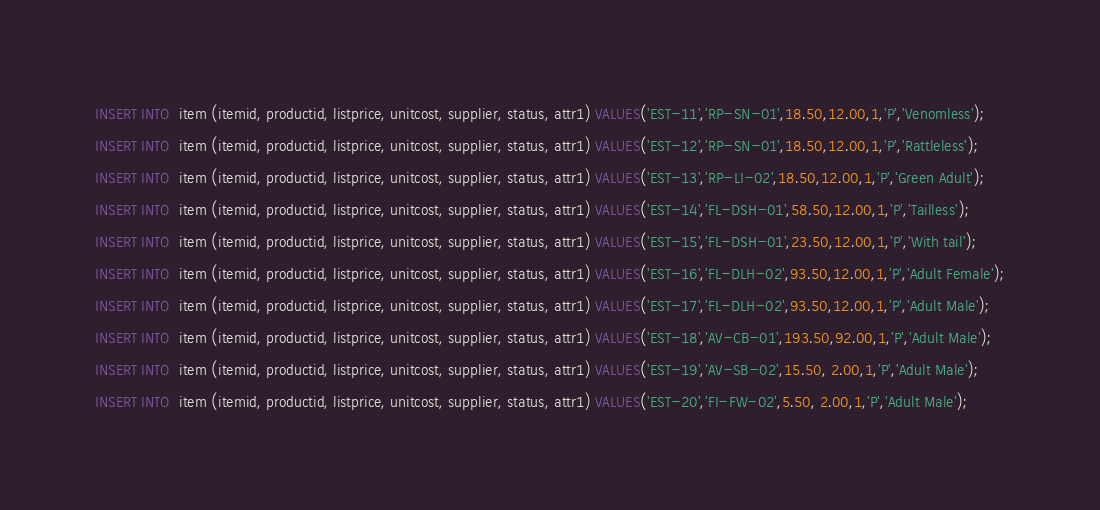Convert code to text. <code><loc_0><loc_0><loc_500><loc_500><_SQL_>INSERT INTO  item (itemid, productid, listprice, unitcost, supplier, status, attr1) VALUES('EST-11','RP-SN-01',18.50,12.00,1,'P','Venomless');
INSERT INTO  item (itemid, productid, listprice, unitcost, supplier, status, attr1) VALUES('EST-12','RP-SN-01',18.50,12.00,1,'P','Rattleless');
INSERT INTO  item (itemid, productid, listprice, unitcost, supplier, status, attr1) VALUES('EST-13','RP-LI-02',18.50,12.00,1,'P','Green Adult');
INSERT INTO  item (itemid, productid, listprice, unitcost, supplier, status, attr1) VALUES('EST-14','FL-DSH-01',58.50,12.00,1,'P','Tailless');
INSERT INTO  item (itemid, productid, listprice, unitcost, supplier, status, attr1) VALUES('EST-15','FL-DSH-01',23.50,12.00,1,'P','With tail');
INSERT INTO  item (itemid, productid, listprice, unitcost, supplier, status, attr1) VALUES('EST-16','FL-DLH-02',93.50,12.00,1,'P','Adult Female');
INSERT INTO  item (itemid, productid, listprice, unitcost, supplier, status, attr1) VALUES('EST-17','FL-DLH-02',93.50,12.00,1,'P','Adult Male');
INSERT INTO  item (itemid, productid, listprice, unitcost, supplier, status, attr1) VALUES('EST-18','AV-CB-01',193.50,92.00,1,'P','Adult Male');
INSERT INTO  item (itemid, productid, listprice, unitcost, supplier, status, attr1) VALUES('EST-19','AV-SB-02',15.50, 2.00,1,'P','Adult Male');
INSERT INTO  item (itemid, productid, listprice, unitcost, supplier, status, attr1) VALUES('EST-20','FI-FW-02',5.50, 2.00,1,'P','Adult Male');</code> 